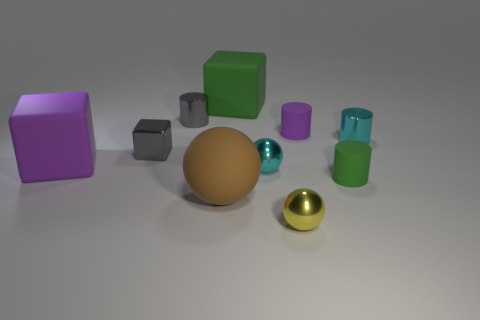Can you count the number of cylinders in the image? Certainly! In the image, there are three cylinders: two are green and positioned upright, and one is lying horizontally with a metallic finish. 